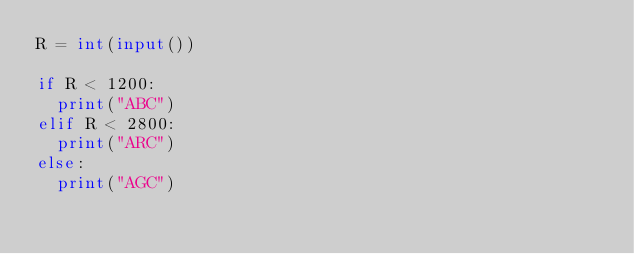<code> <loc_0><loc_0><loc_500><loc_500><_Python_>R = int(input())

if R < 1200:
  print("ABC")
elif R < 2800:
  print("ARC")
else:
  print("AGC")</code> 